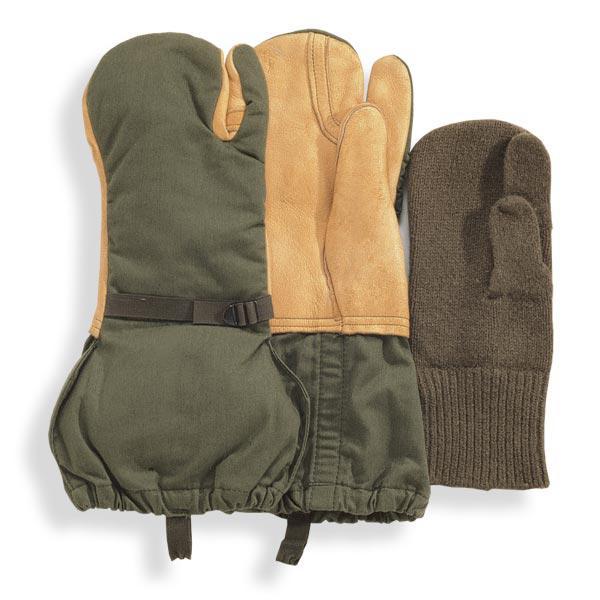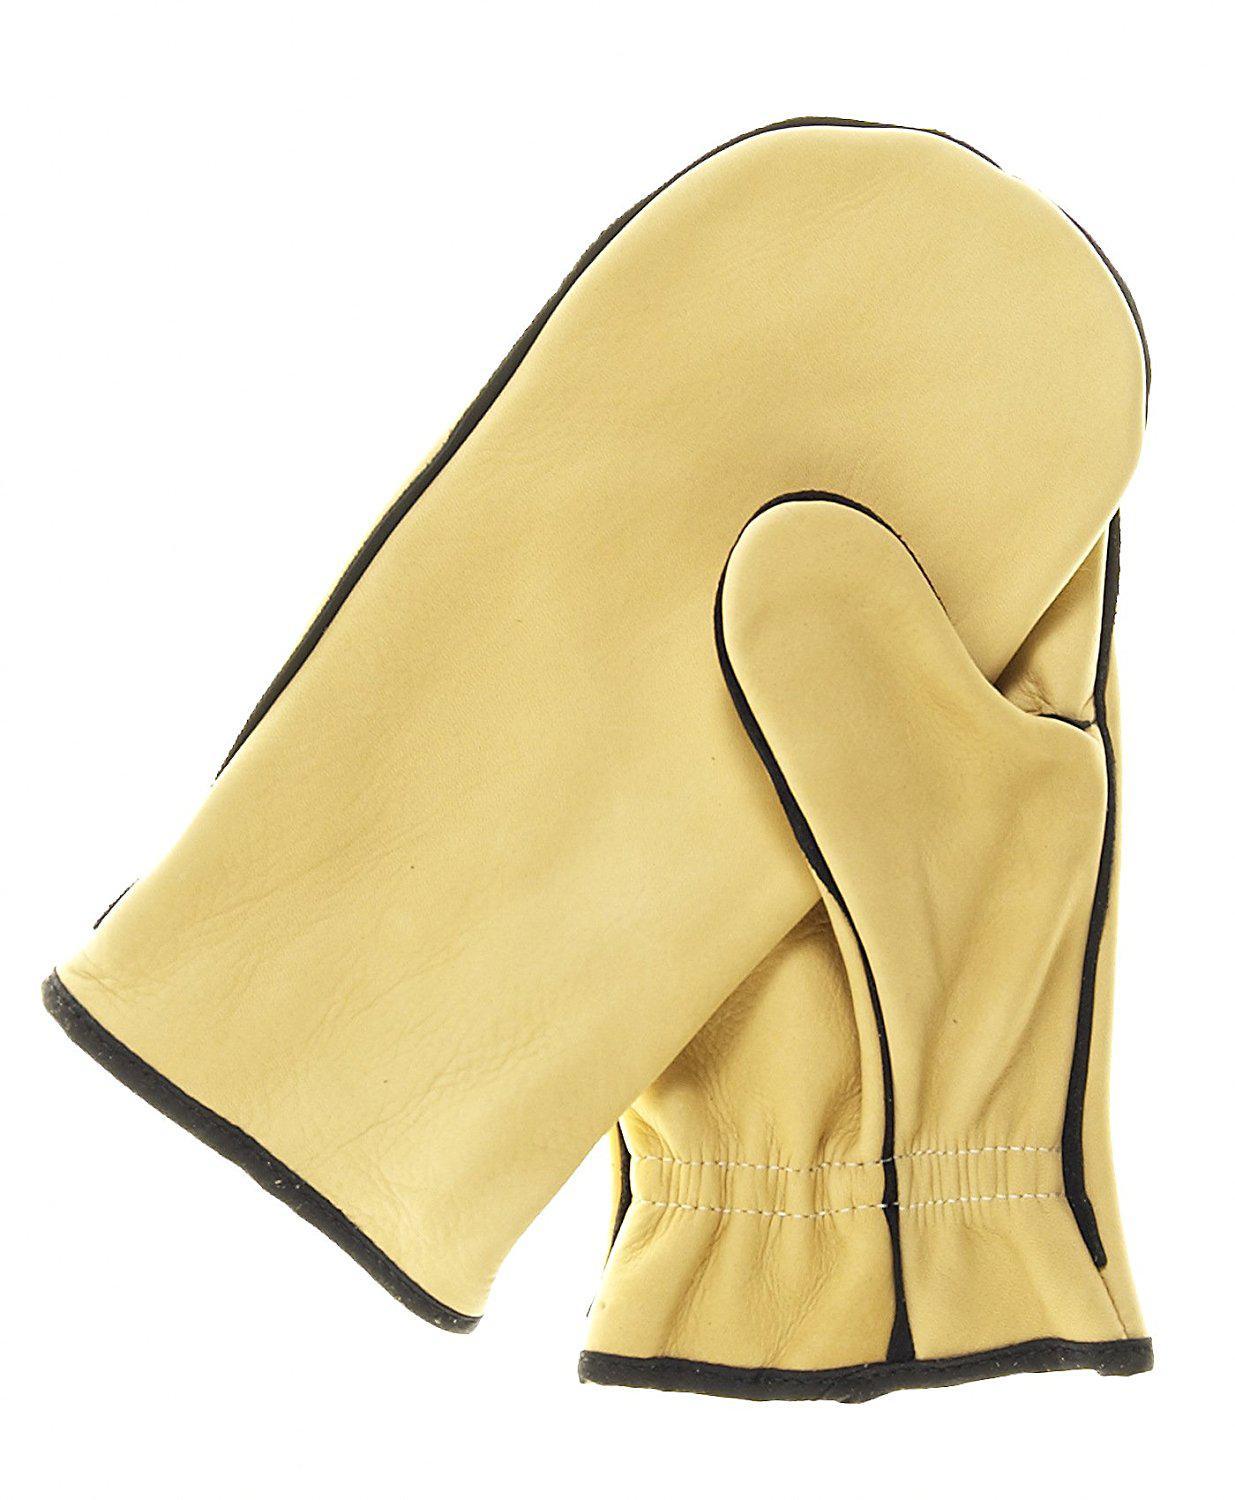The first image is the image on the left, the second image is the image on the right. Analyze the images presented: Is the assertion "One image shows exactly one buff beige mitten overlapping one black mitten." valid? Answer yes or no. No. The first image is the image on the left, the second image is the image on the right. For the images displayed, is the sentence "There are three mittens in the image on the left and a single pair in the image on the right." factually correct? Answer yes or no. Yes. 